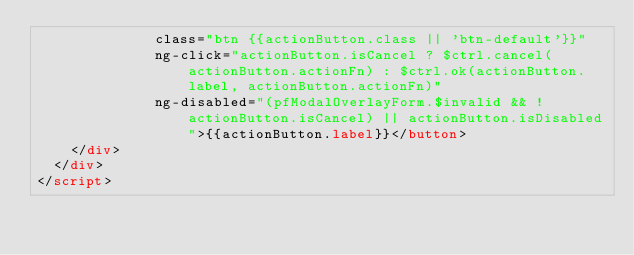Convert code to text. <code><loc_0><loc_0><loc_500><loc_500><_HTML_>              class="btn {{actionButton.class || 'btn-default'}}"
              ng-click="actionButton.isCancel ? $ctrl.cancel(actionButton.actionFn) : $ctrl.ok(actionButton.label, actionButton.actionFn)"
              ng-disabled="(pfModalOverlayForm.$invalid && !actionButton.isCancel) || actionButton.isDisabled">{{actionButton.label}}</button>
    </div>
  </div>
</script>
</code> 